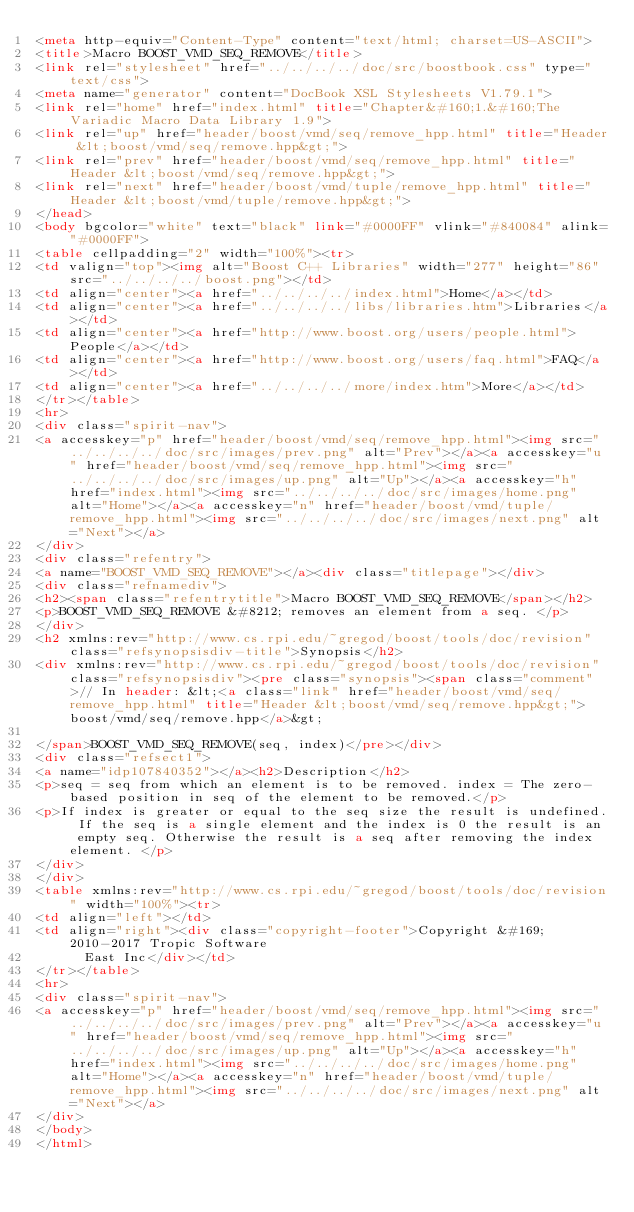Convert code to text. <code><loc_0><loc_0><loc_500><loc_500><_HTML_><meta http-equiv="Content-Type" content="text/html; charset=US-ASCII">
<title>Macro BOOST_VMD_SEQ_REMOVE</title>
<link rel="stylesheet" href="../../../../doc/src/boostbook.css" type="text/css">
<meta name="generator" content="DocBook XSL Stylesheets V1.79.1">
<link rel="home" href="index.html" title="Chapter&#160;1.&#160;The Variadic Macro Data Library 1.9">
<link rel="up" href="header/boost/vmd/seq/remove_hpp.html" title="Header &lt;boost/vmd/seq/remove.hpp&gt;">
<link rel="prev" href="header/boost/vmd/seq/remove_hpp.html" title="Header &lt;boost/vmd/seq/remove.hpp&gt;">
<link rel="next" href="header/boost/vmd/tuple/remove_hpp.html" title="Header &lt;boost/vmd/tuple/remove.hpp&gt;">
</head>
<body bgcolor="white" text="black" link="#0000FF" vlink="#840084" alink="#0000FF">
<table cellpadding="2" width="100%"><tr>
<td valign="top"><img alt="Boost C++ Libraries" width="277" height="86" src="../../../../boost.png"></td>
<td align="center"><a href="../../../../index.html">Home</a></td>
<td align="center"><a href="../../../../libs/libraries.htm">Libraries</a></td>
<td align="center"><a href="http://www.boost.org/users/people.html">People</a></td>
<td align="center"><a href="http://www.boost.org/users/faq.html">FAQ</a></td>
<td align="center"><a href="../../../../more/index.htm">More</a></td>
</tr></table>
<hr>
<div class="spirit-nav">
<a accesskey="p" href="header/boost/vmd/seq/remove_hpp.html"><img src="../../../../doc/src/images/prev.png" alt="Prev"></a><a accesskey="u" href="header/boost/vmd/seq/remove_hpp.html"><img src="../../../../doc/src/images/up.png" alt="Up"></a><a accesskey="h" href="index.html"><img src="../../../../doc/src/images/home.png" alt="Home"></a><a accesskey="n" href="header/boost/vmd/tuple/remove_hpp.html"><img src="../../../../doc/src/images/next.png" alt="Next"></a>
</div>
<div class="refentry">
<a name="BOOST_VMD_SEQ_REMOVE"></a><div class="titlepage"></div>
<div class="refnamediv">
<h2><span class="refentrytitle">Macro BOOST_VMD_SEQ_REMOVE</span></h2>
<p>BOOST_VMD_SEQ_REMOVE &#8212; removes an element from a seq. </p>
</div>
<h2 xmlns:rev="http://www.cs.rpi.edu/~gregod/boost/tools/doc/revision" class="refsynopsisdiv-title">Synopsis</h2>
<div xmlns:rev="http://www.cs.rpi.edu/~gregod/boost/tools/doc/revision" class="refsynopsisdiv"><pre class="synopsis"><span class="comment">// In header: &lt;<a class="link" href="header/boost/vmd/seq/remove_hpp.html" title="Header &lt;boost/vmd/seq/remove.hpp&gt;">boost/vmd/seq/remove.hpp</a>&gt;

</span>BOOST_VMD_SEQ_REMOVE(seq, index)</pre></div>
<div class="refsect1">
<a name="idp107840352"></a><h2>Description</h2>
<p>seq = seq from which an element is to be removed. index = The zero-based position in seq of the element to be removed.</p>
<p>If index is greater or equal to the seq size the result is undefined. If the seq is a single element and the index is 0 the result is an empty seq. Otherwise the result is a seq after removing the index element. </p>
</div>
</div>
<table xmlns:rev="http://www.cs.rpi.edu/~gregod/boost/tools/doc/revision" width="100%"><tr>
<td align="left"></td>
<td align="right"><div class="copyright-footer">Copyright &#169; 2010-2017 Tropic Software
      East Inc</div></td>
</tr></table>
<hr>
<div class="spirit-nav">
<a accesskey="p" href="header/boost/vmd/seq/remove_hpp.html"><img src="../../../../doc/src/images/prev.png" alt="Prev"></a><a accesskey="u" href="header/boost/vmd/seq/remove_hpp.html"><img src="../../../../doc/src/images/up.png" alt="Up"></a><a accesskey="h" href="index.html"><img src="../../../../doc/src/images/home.png" alt="Home"></a><a accesskey="n" href="header/boost/vmd/tuple/remove_hpp.html"><img src="../../../../doc/src/images/next.png" alt="Next"></a>
</div>
</body>
</html>
</code> 